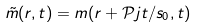Convert formula to latex. <formula><loc_0><loc_0><loc_500><loc_500>\tilde { m } ( r , t ) = m ( r + \mathcal { P } j t / s _ { 0 } , t )</formula> 